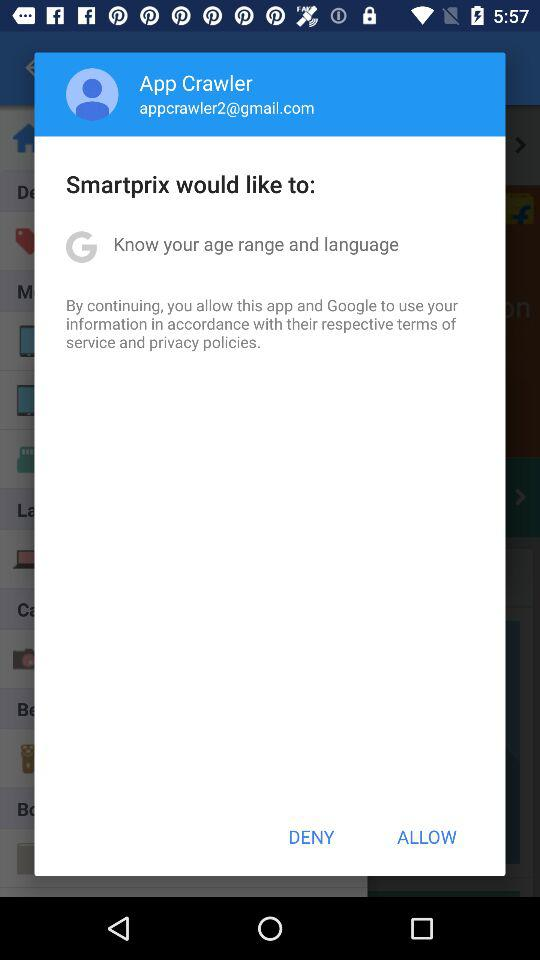What is the email address? The email address is appcrawler2@gmail.com. 